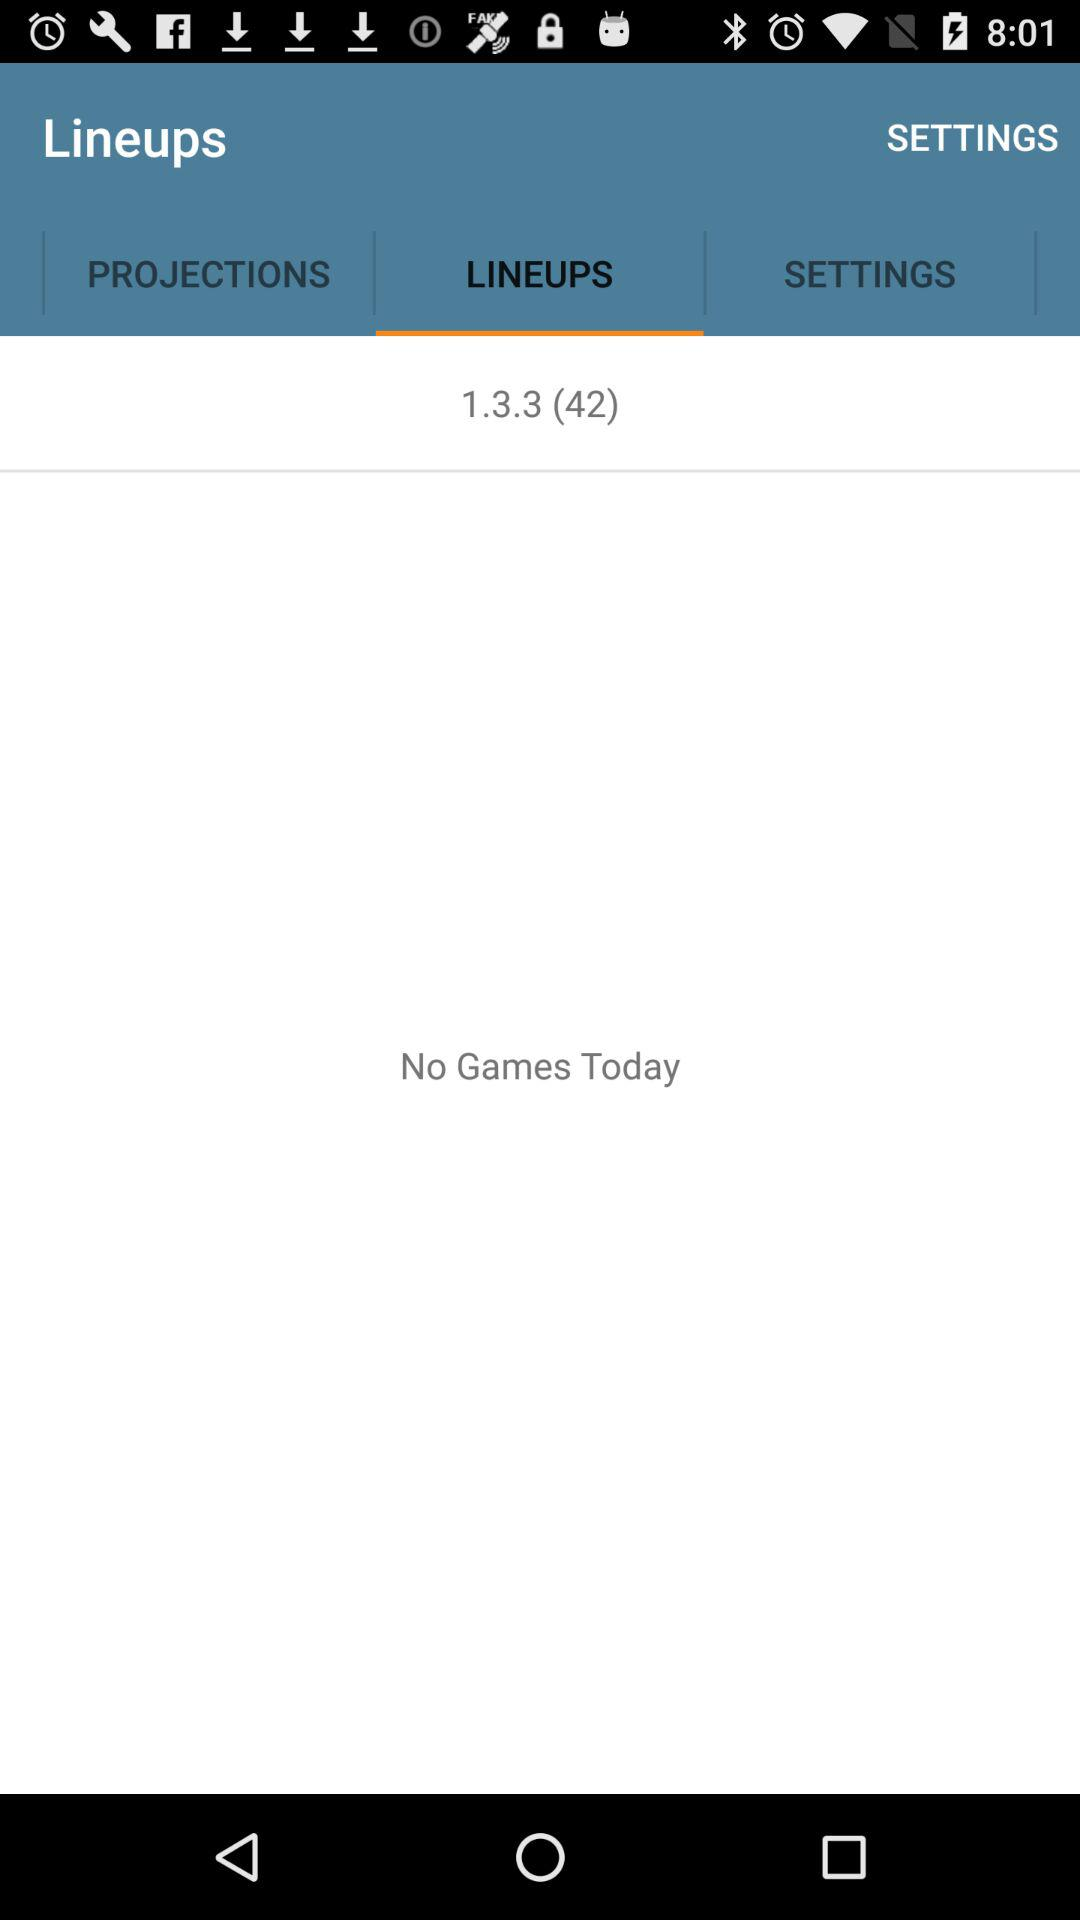What is the selected tab? The selected tab is "LINEUPS". 